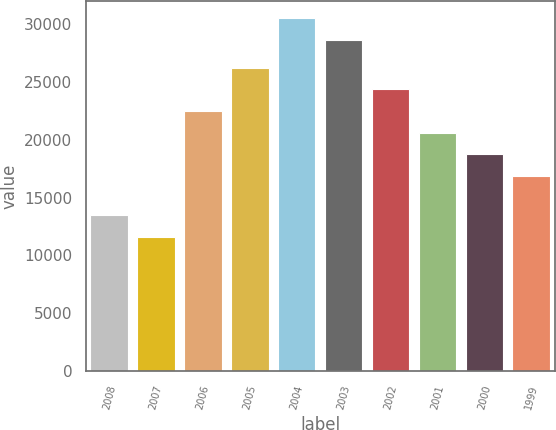Convert chart. <chart><loc_0><loc_0><loc_500><loc_500><bar_chart><fcel>2008<fcel>2007<fcel>2006<fcel>2005<fcel>2004<fcel>2003<fcel>2002<fcel>2001<fcel>2000<fcel>1999<nl><fcel>13495.2<fcel>11630<fcel>22496.6<fcel>26227<fcel>30505.2<fcel>28640<fcel>24361.8<fcel>20631.4<fcel>18766.2<fcel>16901<nl></chart> 